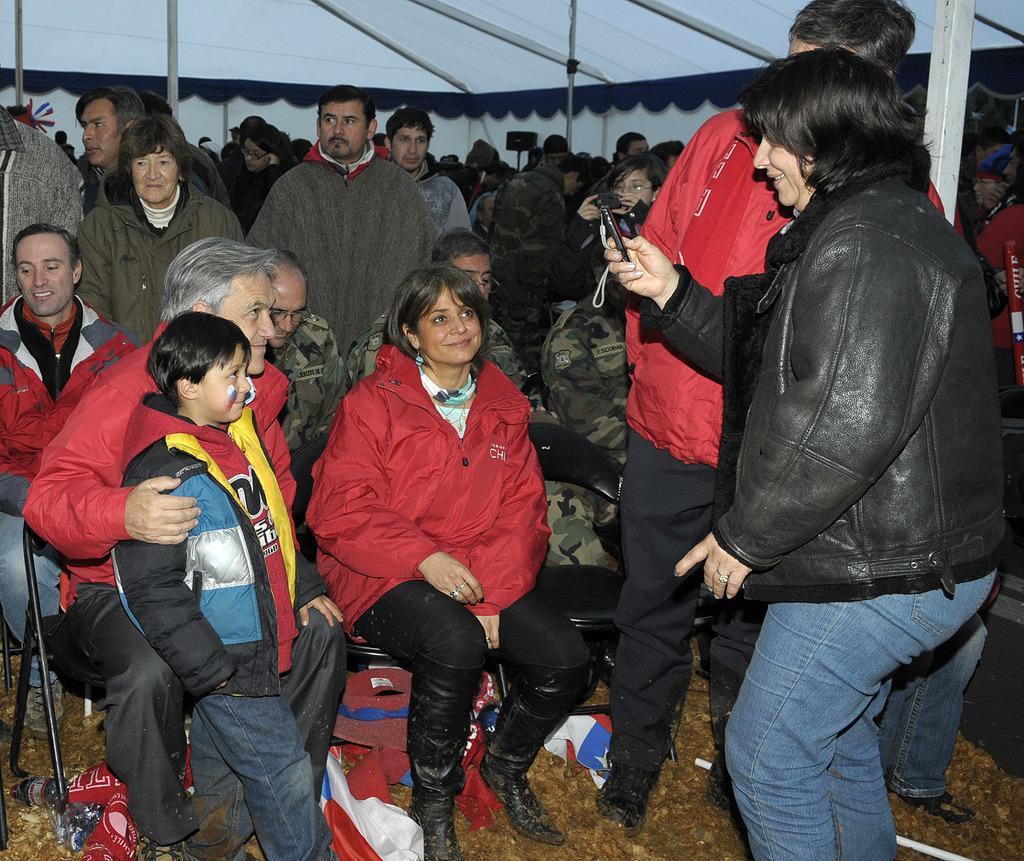Can you describe this image briefly? In this image, we can see a group of people. Few are standing and sitting. Here we can see a person is holding and object. Few people are smiling. Background we can see a tent, rods. 